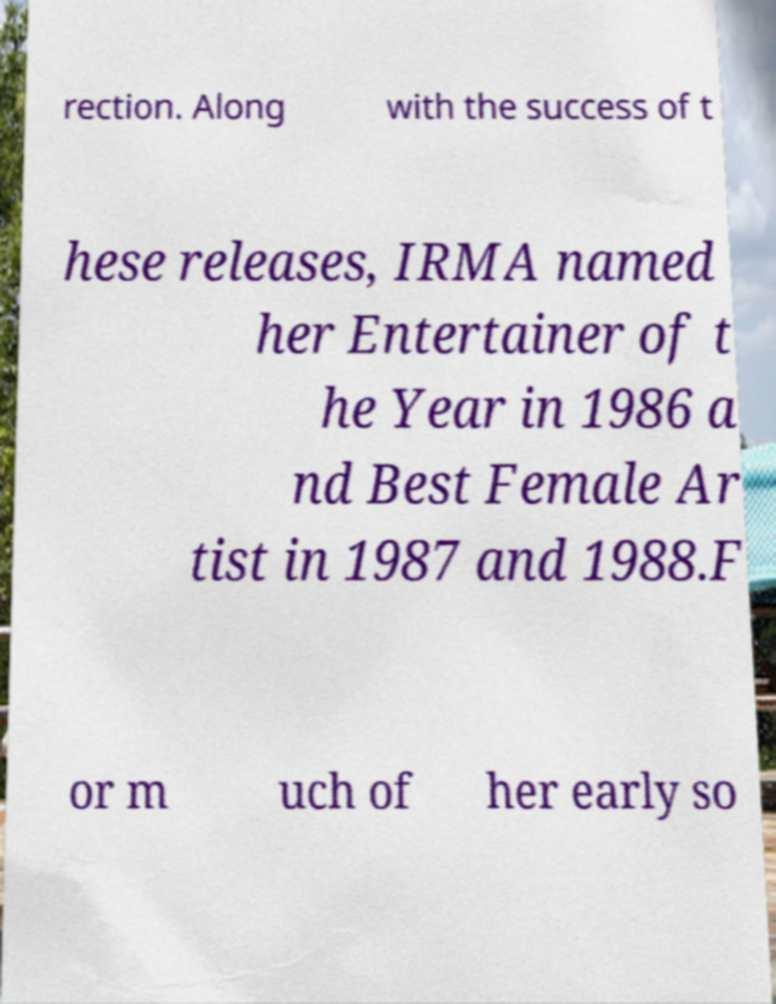Could you extract and type out the text from this image? rection. Along with the success of t hese releases, IRMA named her Entertainer of t he Year in 1986 a nd Best Female Ar tist in 1987 and 1988.F or m uch of her early so 